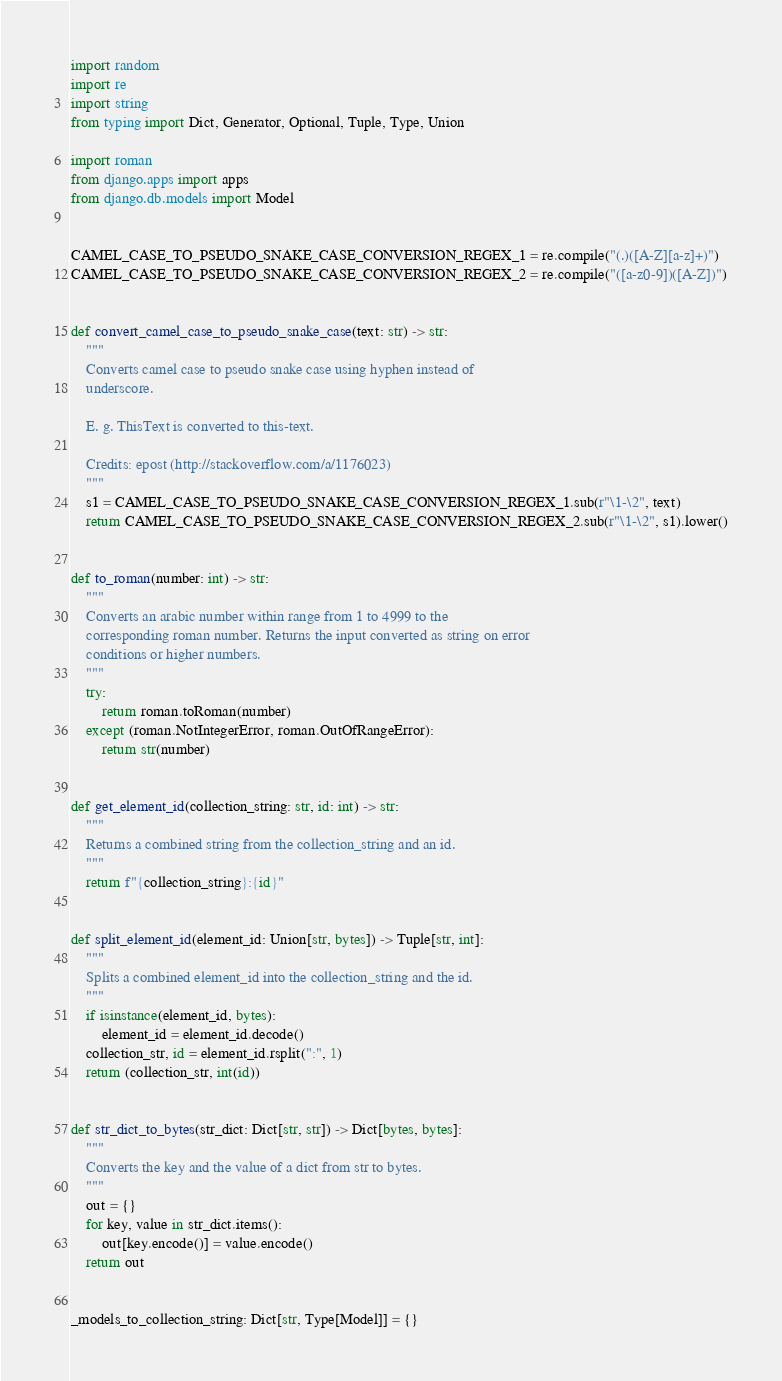Convert code to text. <code><loc_0><loc_0><loc_500><loc_500><_Python_>import random
import re
import string
from typing import Dict, Generator, Optional, Tuple, Type, Union

import roman
from django.apps import apps
from django.db.models import Model


CAMEL_CASE_TO_PSEUDO_SNAKE_CASE_CONVERSION_REGEX_1 = re.compile("(.)([A-Z][a-z]+)")
CAMEL_CASE_TO_PSEUDO_SNAKE_CASE_CONVERSION_REGEX_2 = re.compile("([a-z0-9])([A-Z])")


def convert_camel_case_to_pseudo_snake_case(text: str) -> str:
    """
    Converts camel case to pseudo snake case using hyphen instead of
    underscore.

    E. g. ThisText is converted to this-text.

    Credits: epost (http://stackoverflow.com/a/1176023)
    """
    s1 = CAMEL_CASE_TO_PSEUDO_SNAKE_CASE_CONVERSION_REGEX_1.sub(r"\1-\2", text)
    return CAMEL_CASE_TO_PSEUDO_SNAKE_CASE_CONVERSION_REGEX_2.sub(r"\1-\2", s1).lower()


def to_roman(number: int) -> str:
    """
    Converts an arabic number within range from 1 to 4999 to the
    corresponding roman number. Returns the input converted as string on error
    conditions or higher numbers.
    """
    try:
        return roman.toRoman(number)
    except (roman.NotIntegerError, roman.OutOfRangeError):
        return str(number)


def get_element_id(collection_string: str, id: int) -> str:
    """
    Returns a combined string from the collection_string and an id.
    """
    return f"{collection_string}:{id}"


def split_element_id(element_id: Union[str, bytes]) -> Tuple[str, int]:
    """
    Splits a combined element_id into the collection_string and the id.
    """
    if isinstance(element_id, bytes):
        element_id = element_id.decode()
    collection_str, id = element_id.rsplit(":", 1)
    return (collection_str, int(id))


def str_dict_to_bytes(str_dict: Dict[str, str]) -> Dict[bytes, bytes]:
    """
    Converts the key and the value of a dict from str to bytes.
    """
    out = {}
    for key, value in str_dict.items():
        out[key.encode()] = value.encode()
    return out


_models_to_collection_string: Dict[str, Type[Model]] = {}

</code> 